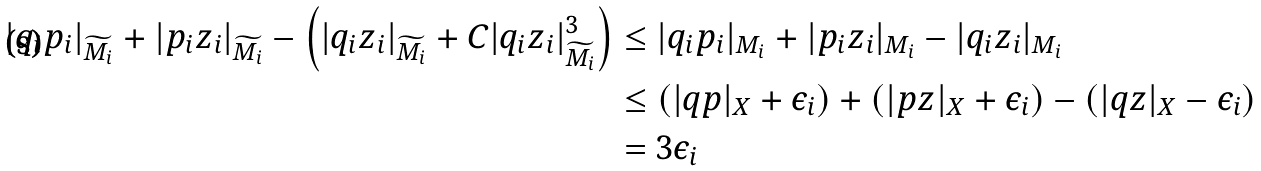Convert formula to latex. <formula><loc_0><loc_0><loc_500><loc_500>| q _ { i } p _ { i } | _ { \widetilde { M _ { i } } } + | p _ { i } z _ { i } | _ { \widetilde { M _ { i } } } - \left ( | q _ { i } z _ { i } | _ { \widetilde { M _ { i } } } + C | q _ { i } z _ { i } | _ { \widetilde { M _ { i } } } ^ { 3 } \right ) & \leq | q _ { i } p _ { i } | _ { M _ { i } } + | p _ { i } z _ { i } | _ { M _ { i } } - | q _ { i } z _ { i } | _ { M _ { i } } \\ & \leq ( | q p | _ { X } + \epsilon _ { i } ) + ( | p z | _ { X } + \epsilon _ { i } ) - ( | q z | _ { X } - \epsilon _ { i } ) \\ & = 3 { \epsilon } _ { i }</formula> 